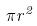<formula> <loc_0><loc_0><loc_500><loc_500>\pi r ^ { 2 }</formula> 